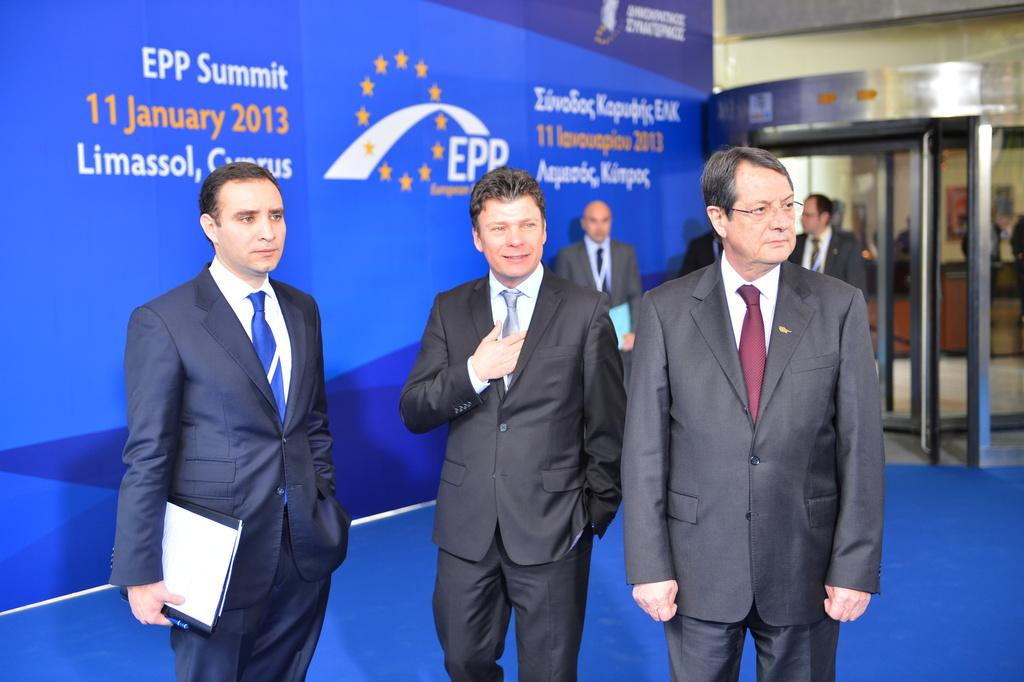How many people are in the image? There is a group of people in the image. What are some people holding in the image? Some people are holding files in the image. What can be seen in the background of the image? There is a hoarding in the background of the image. What type of beetle can be seen crawling on the hoarding in the image? There is no beetle present in the image; the hoarding is the only visible object in the background. 